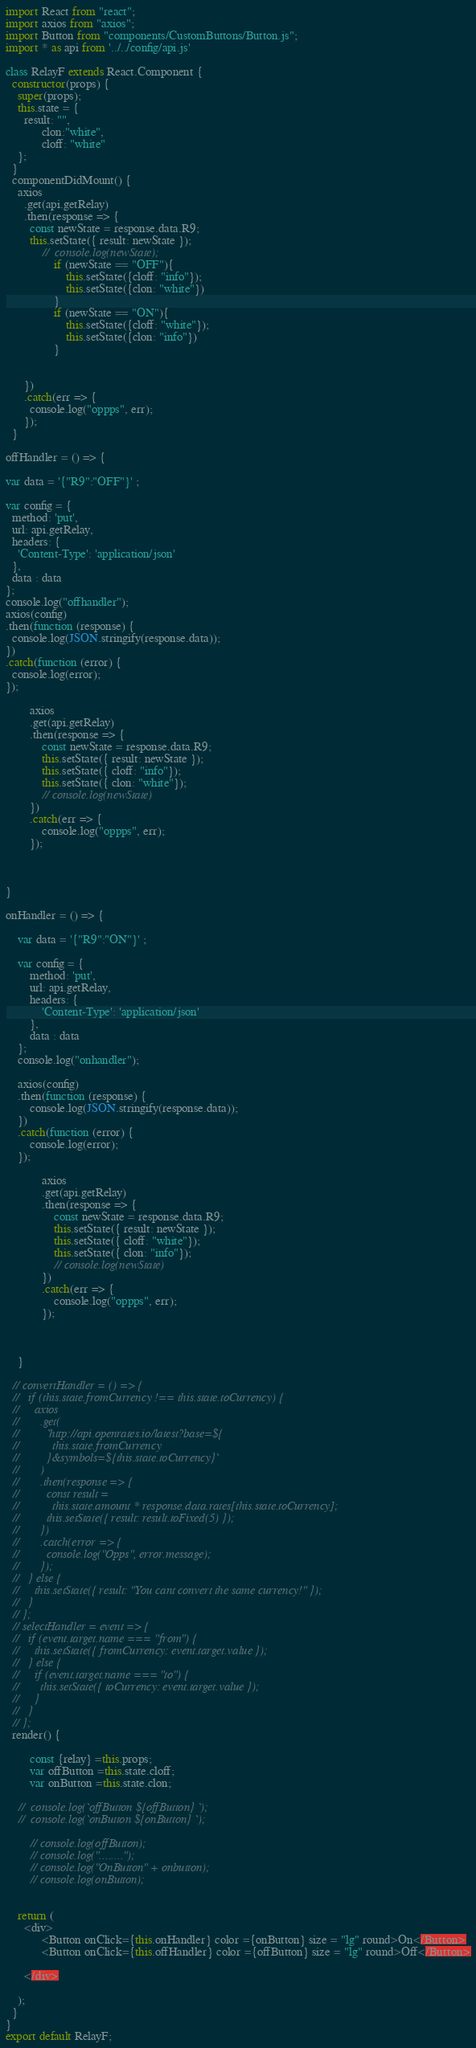Convert code to text. <code><loc_0><loc_0><loc_500><loc_500><_JavaScript_>import React from "react";
import axios from "axios";
import Button from "components/CustomButtons/Button.js";
import * as api from '../../config/api.js'

class RelayF extends React.Component {
  constructor(props) {
    super(props);
    this.state = {
      result: "",
			clon:"white",
			cloff: "white"
    };
  }
  componentDidMount() {
    axios
      .get(api.getRelay)
      .then(response => {
        const newState = response.data.R9;
        this.setState({ result: newState });
			//	console.log(newState);
				if (newState == "OFF"){
					this.setState({cloff: "info"});
					this.setState({clon: "white"})
				}
				if (newState == "ON"){
					this.setState({cloff: "white"});
					this.setState({clon: "info"})
				}
				
				
      })
      .catch(err => {
        console.log("oppps", err);
      });
  }

offHandler = () => {

var data = '{"R9":"OFF"}' ;

var config = {
  method: 'put',
  url: api.getRelay,
  headers: { 
    'Content-Type': 'application/json'
  },
  data : data
};
console.log("offhandler");
axios(config)
.then(function (response) {
  console.log(JSON.stringify(response.data));
})
.catch(function (error) {
  console.log(error);
});

		axios
		.get(api.getRelay)
		.then(response => {
			const newState = response.data.R9;
			this.setState({ result: newState });
			this.setState({ cloff: "info"});
			this.setState({ clon: "white"});
			// console.log(newState)
		})
		.catch(err => {
			console.log("oppps", err);
		});



}

onHandler = () => {

	var data = '{"R9":"ON"}' ;
	
	var config = {
		method: 'put',
		url: api.getRelay,
		headers: { 
			'Content-Type': 'application/json'
		},
		data : data
	};
	console.log("onhandler");

	axios(config)
	.then(function (response) {
		console.log(JSON.stringify(response.data));
	})
	.catch(function (error) {
		console.log(error);
	});
	
			axios
			.get(api.getRelay)
			.then(response => {
				const newState = response.data.R9;
				this.setState({ result: newState });
				this.setState({ cloff: "white"});
				this.setState({ clon: "info"});
				// console.log(newState)
			})
			.catch(err => {
				console.log("oppps", err);
			});
	
	
	
	}

  // convertHandler = () => {
  //   if (this.state.fromCurrency !== this.state.toCurrency) {
  //     axios
  //       .get(
  //         `http://api.openrates.io/latest?base=${
  //           this.state.fromCurrency
  //         }&symbols=${this.state.toCurrency}`
  //       )
  //       .then(response => {
  //         const result =
  //           this.state.amount * response.data.rates[this.state.toCurrency];
  //         this.setState({ result: result.toFixed(5) });
  //       })
  //       .catch(error => {
  //         console.log("Opps", error.message);
  //       });
  //   } else {
  //     this.setState({ result: "You cant convert the same currency!" });
  //   }
  // };
  // selectHandler = event => {
  //   if (event.target.name === "from") {
  //     this.setState({ fromCurrency: event.target.value });
  //   } else {
  //     if (event.target.name === "to") {
  //       this.setState({ toCurrency: event.target.value });
  //     }
  //   }
  // };
  render() {
		
		const {relay} =this.props;
		var offButton =this.state.cloff;
		var onButton =this.state.clon;

	//	console.log(`offButton ${offButton} `);
	//	console.log(`onButton ${onButton} `);
		
		// console.log(offButton);
		// console.log("........");
		// console.log("OnButton" + onbutton);
		// console.log(onButton);
		

    return (
      <div>
			<Button onClick={this.onHandler} color ={onButton} size = "lg" round>On</Button>
			<Button onClick={this.offHandler} color ={offButton} size = "lg" round>Off</Button>
       
      </div>
      
    );
  }
}
export default RelayF;</code> 